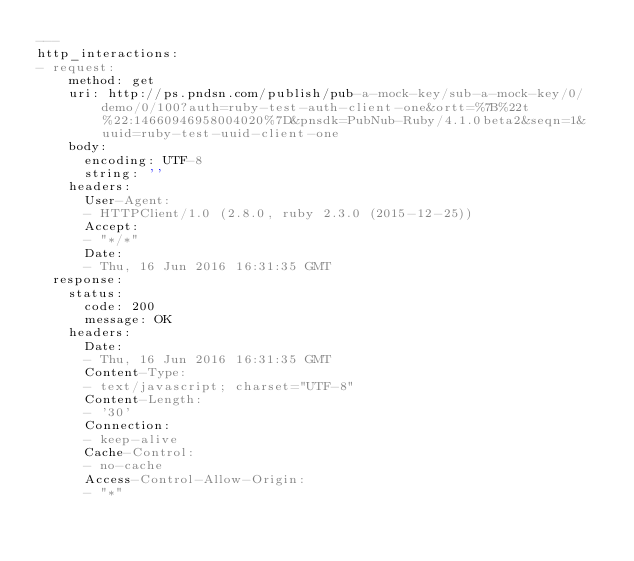<code> <loc_0><loc_0><loc_500><loc_500><_YAML_>---
http_interactions:
- request:
    method: get
    uri: http://ps.pndsn.com/publish/pub-a-mock-key/sub-a-mock-key/0/demo/0/100?auth=ruby-test-auth-client-one&ortt=%7B%22t%22:14660946958004020%7D&pnsdk=PubNub-Ruby/4.1.0beta2&seqn=1&uuid=ruby-test-uuid-client-one
    body:
      encoding: UTF-8
      string: ''
    headers:
      User-Agent:
      - HTTPClient/1.0 (2.8.0, ruby 2.3.0 (2015-12-25))
      Accept:
      - "*/*"
      Date:
      - Thu, 16 Jun 2016 16:31:35 GMT
  response:
    status:
      code: 200
      message: OK
    headers:
      Date:
      - Thu, 16 Jun 2016 16:31:35 GMT
      Content-Type:
      - text/javascript; charset="UTF-8"
      Content-Length:
      - '30'
      Connection:
      - keep-alive
      Cache-Control:
      - no-cache
      Access-Control-Allow-Origin:
      - "*"</code> 